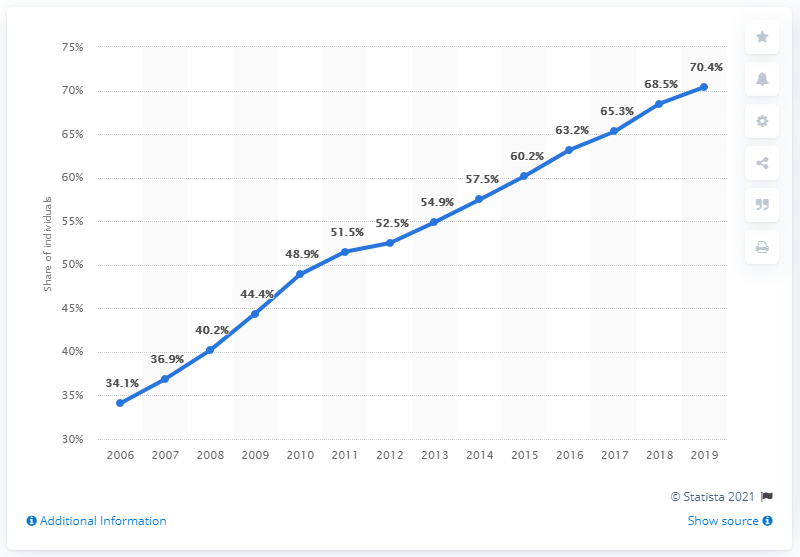Draw attention to some important aspects in this diagram. In 2019, the internet penetration rate in Italy was 70.4%. In 2013, the share of individuals using the internet was 54.9%. In 2009, 44.4% of the Italian population used the internet. In 2018 and 2019, the percentage of individuals using the internet was 138.9.. 